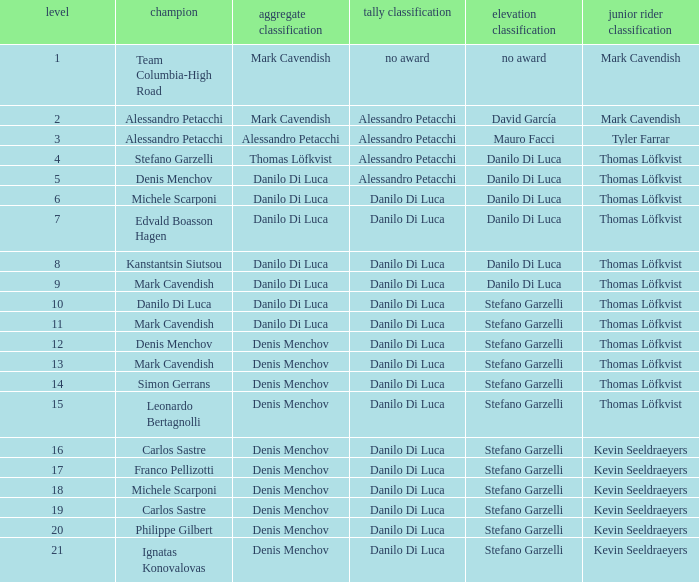When thomas löfkvist is the  young rider classification and alessandro petacchi is the points classification who are the general classifications?  Thomas Löfkvist, Danilo Di Luca. 